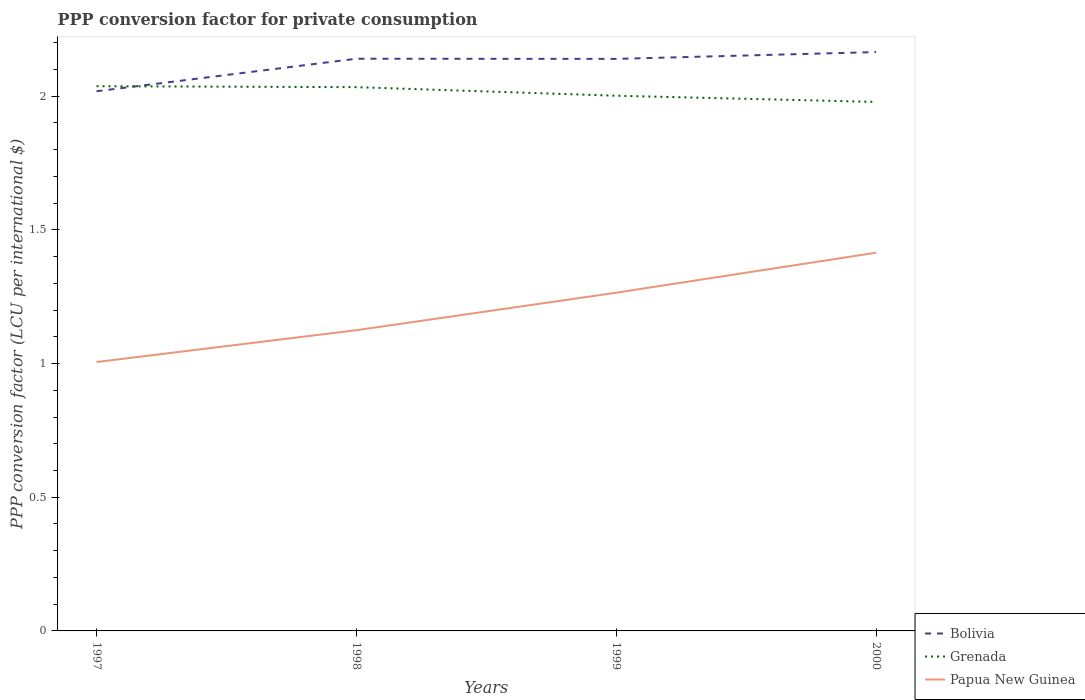Does the line corresponding to Bolivia intersect with the line corresponding to Grenada?
Provide a succinct answer. Yes. Is the number of lines equal to the number of legend labels?
Your answer should be very brief. Yes. Across all years, what is the maximum PPP conversion factor for private consumption in Grenada?
Make the answer very short. 1.98. In which year was the PPP conversion factor for private consumption in Grenada maximum?
Offer a very short reply. 2000. What is the total PPP conversion factor for private consumption in Bolivia in the graph?
Give a very brief answer. -0.03. What is the difference between the highest and the second highest PPP conversion factor for private consumption in Bolivia?
Give a very brief answer. 0.15. What is the difference between the highest and the lowest PPP conversion factor for private consumption in Grenada?
Your answer should be very brief. 2. Is the PPP conversion factor for private consumption in Papua New Guinea strictly greater than the PPP conversion factor for private consumption in Bolivia over the years?
Your answer should be compact. Yes. How many lines are there?
Your response must be concise. 3. What is the difference between two consecutive major ticks on the Y-axis?
Your answer should be very brief. 0.5. Does the graph contain any zero values?
Keep it short and to the point. No. Does the graph contain grids?
Offer a terse response. No. How are the legend labels stacked?
Offer a terse response. Vertical. What is the title of the graph?
Offer a terse response. PPP conversion factor for private consumption. Does "St. Vincent and the Grenadines" appear as one of the legend labels in the graph?
Give a very brief answer. No. What is the label or title of the X-axis?
Provide a succinct answer. Years. What is the label or title of the Y-axis?
Make the answer very short. PPP conversion factor (LCU per international $). What is the PPP conversion factor (LCU per international $) in Bolivia in 1997?
Offer a terse response. 2.02. What is the PPP conversion factor (LCU per international $) in Grenada in 1997?
Ensure brevity in your answer.  2.04. What is the PPP conversion factor (LCU per international $) in Papua New Guinea in 1997?
Your answer should be very brief. 1.01. What is the PPP conversion factor (LCU per international $) of Bolivia in 1998?
Provide a short and direct response. 2.14. What is the PPP conversion factor (LCU per international $) of Grenada in 1998?
Your answer should be very brief. 2.03. What is the PPP conversion factor (LCU per international $) in Papua New Guinea in 1998?
Offer a terse response. 1.12. What is the PPP conversion factor (LCU per international $) in Bolivia in 1999?
Offer a terse response. 2.14. What is the PPP conversion factor (LCU per international $) of Grenada in 1999?
Provide a succinct answer. 2. What is the PPP conversion factor (LCU per international $) in Papua New Guinea in 1999?
Offer a very short reply. 1.27. What is the PPP conversion factor (LCU per international $) of Bolivia in 2000?
Make the answer very short. 2.17. What is the PPP conversion factor (LCU per international $) of Grenada in 2000?
Provide a short and direct response. 1.98. What is the PPP conversion factor (LCU per international $) in Papua New Guinea in 2000?
Make the answer very short. 1.41. Across all years, what is the maximum PPP conversion factor (LCU per international $) of Bolivia?
Give a very brief answer. 2.17. Across all years, what is the maximum PPP conversion factor (LCU per international $) of Grenada?
Your answer should be compact. 2.04. Across all years, what is the maximum PPP conversion factor (LCU per international $) in Papua New Guinea?
Provide a short and direct response. 1.41. Across all years, what is the minimum PPP conversion factor (LCU per international $) of Bolivia?
Ensure brevity in your answer.  2.02. Across all years, what is the minimum PPP conversion factor (LCU per international $) in Grenada?
Make the answer very short. 1.98. Across all years, what is the minimum PPP conversion factor (LCU per international $) of Papua New Guinea?
Offer a very short reply. 1.01. What is the total PPP conversion factor (LCU per international $) in Bolivia in the graph?
Provide a succinct answer. 8.46. What is the total PPP conversion factor (LCU per international $) in Grenada in the graph?
Ensure brevity in your answer.  8.05. What is the total PPP conversion factor (LCU per international $) in Papua New Guinea in the graph?
Your response must be concise. 4.81. What is the difference between the PPP conversion factor (LCU per international $) in Bolivia in 1997 and that in 1998?
Provide a succinct answer. -0.12. What is the difference between the PPP conversion factor (LCU per international $) in Grenada in 1997 and that in 1998?
Give a very brief answer. 0. What is the difference between the PPP conversion factor (LCU per international $) of Papua New Guinea in 1997 and that in 1998?
Provide a short and direct response. -0.12. What is the difference between the PPP conversion factor (LCU per international $) in Bolivia in 1997 and that in 1999?
Your response must be concise. -0.12. What is the difference between the PPP conversion factor (LCU per international $) in Grenada in 1997 and that in 1999?
Give a very brief answer. 0.04. What is the difference between the PPP conversion factor (LCU per international $) of Papua New Guinea in 1997 and that in 1999?
Your answer should be compact. -0.26. What is the difference between the PPP conversion factor (LCU per international $) of Bolivia in 1997 and that in 2000?
Your answer should be very brief. -0.15. What is the difference between the PPP conversion factor (LCU per international $) of Grenada in 1997 and that in 2000?
Keep it short and to the point. 0.06. What is the difference between the PPP conversion factor (LCU per international $) in Papua New Guinea in 1997 and that in 2000?
Your answer should be very brief. -0.41. What is the difference between the PPP conversion factor (LCU per international $) in Bolivia in 1998 and that in 1999?
Provide a short and direct response. 0. What is the difference between the PPP conversion factor (LCU per international $) of Grenada in 1998 and that in 1999?
Keep it short and to the point. 0.03. What is the difference between the PPP conversion factor (LCU per international $) of Papua New Guinea in 1998 and that in 1999?
Your answer should be compact. -0.14. What is the difference between the PPP conversion factor (LCU per international $) in Bolivia in 1998 and that in 2000?
Your response must be concise. -0.02. What is the difference between the PPP conversion factor (LCU per international $) of Grenada in 1998 and that in 2000?
Ensure brevity in your answer.  0.06. What is the difference between the PPP conversion factor (LCU per international $) of Papua New Guinea in 1998 and that in 2000?
Offer a very short reply. -0.29. What is the difference between the PPP conversion factor (LCU per international $) in Bolivia in 1999 and that in 2000?
Provide a succinct answer. -0.03. What is the difference between the PPP conversion factor (LCU per international $) in Grenada in 1999 and that in 2000?
Your answer should be very brief. 0.02. What is the difference between the PPP conversion factor (LCU per international $) of Papua New Guinea in 1999 and that in 2000?
Offer a very short reply. -0.15. What is the difference between the PPP conversion factor (LCU per international $) in Bolivia in 1997 and the PPP conversion factor (LCU per international $) in Grenada in 1998?
Your response must be concise. -0.02. What is the difference between the PPP conversion factor (LCU per international $) of Bolivia in 1997 and the PPP conversion factor (LCU per international $) of Papua New Guinea in 1998?
Offer a terse response. 0.89. What is the difference between the PPP conversion factor (LCU per international $) of Grenada in 1997 and the PPP conversion factor (LCU per international $) of Papua New Guinea in 1998?
Keep it short and to the point. 0.91. What is the difference between the PPP conversion factor (LCU per international $) in Bolivia in 1997 and the PPP conversion factor (LCU per international $) in Grenada in 1999?
Offer a very short reply. 0.02. What is the difference between the PPP conversion factor (LCU per international $) in Bolivia in 1997 and the PPP conversion factor (LCU per international $) in Papua New Guinea in 1999?
Offer a very short reply. 0.75. What is the difference between the PPP conversion factor (LCU per international $) of Grenada in 1997 and the PPP conversion factor (LCU per international $) of Papua New Guinea in 1999?
Offer a very short reply. 0.77. What is the difference between the PPP conversion factor (LCU per international $) of Bolivia in 1997 and the PPP conversion factor (LCU per international $) of Grenada in 2000?
Provide a succinct answer. 0.04. What is the difference between the PPP conversion factor (LCU per international $) in Bolivia in 1997 and the PPP conversion factor (LCU per international $) in Papua New Guinea in 2000?
Make the answer very short. 0.6. What is the difference between the PPP conversion factor (LCU per international $) in Grenada in 1997 and the PPP conversion factor (LCU per international $) in Papua New Guinea in 2000?
Provide a short and direct response. 0.62. What is the difference between the PPP conversion factor (LCU per international $) of Bolivia in 1998 and the PPP conversion factor (LCU per international $) of Grenada in 1999?
Provide a short and direct response. 0.14. What is the difference between the PPP conversion factor (LCU per international $) in Bolivia in 1998 and the PPP conversion factor (LCU per international $) in Papua New Guinea in 1999?
Make the answer very short. 0.88. What is the difference between the PPP conversion factor (LCU per international $) in Grenada in 1998 and the PPP conversion factor (LCU per international $) in Papua New Guinea in 1999?
Ensure brevity in your answer.  0.77. What is the difference between the PPP conversion factor (LCU per international $) in Bolivia in 1998 and the PPP conversion factor (LCU per international $) in Grenada in 2000?
Offer a terse response. 0.16. What is the difference between the PPP conversion factor (LCU per international $) of Bolivia in 1998 and the PPP conversion factor (LCU per international $) of Papua New Guinea in 2000?
Ensure brevity in your answer.  0.73. What is the difference between the PPP conversion factor (LCU per international $) of Grenada in 1998 and the PPP conversion factor (LCU per international $) of Papua New Guinea in 2000?
Provide a short and direct response. 0.62. What is the difference between the PPP conversion factor (LCU per international $) of Bolivia in 1999 and the PPP conversion factor (LCU per international $) of Grenada in 2000?
Make the answer very short. 0.16. What is the difference between the PPP conversion factor (LCU per international $) in Bolivia in 1999 and the PPP conversion factor (LCU per international $) in Papua New Guinea in 2000?
Your answer should be very brief. 0.72. What is the difference between the PPP conversion factor (LCU per international $) in Grenada in 1999 and the PPP conversion factor (LCU per international $) in Papua New Guinea in 2000?
Your answer should be compact. 0.59. What is the average PPP conversion factor (LCU per international $) of Bolivia per year?
Provide a succinct answer. 2.12. What is the average PPP conversion factor (LCU per international $) of Grenada per year?
Your response must be concise. 2.01. What is the average PPP conversion factor (LCU per international $) of Papua New Guinea per year?
Your answer should be compact. 1.2. In the year 1997, what is the difference between the PPP conversion factor (LCU per international $) of Bolivia and PPP conversion factor (LCU per international $) of Grenada?
Your answer should be compact. -0.02. In the year 1997, what is the difference between the PPP conversion factor (LCU per international $) of Bolivia and PPP conversion factor (LCU per international $) of Papua New Guinea?
Your response must be concise. 1.01. In the year 1997, what is the difference between the PPP conversion factor (LCU per international $) of Grenada and PPP conversion factor (LCU per international $) of Papua New Guinea?
Your answer should be compact. 1.03. In the year 1998, what is the difference between the PPP conversion factor (LCU per international $) of Bolivia and PPP conversion factor (LCU per international $) of Grenada?
Provide a short and direct response. 0.11. In the year 1998, what is the difference between the PPP conversion factor (LCU per international $) of Bolivia and PPP conversion factor (LCU per international $) of Papua New Guinea?
Your answer should be very brief. 1.02. In the year 1999, what is the difference between the PPP conversion factor (LCU per international $) in Bolivia and PPP conversion factor (LCU per international $) in Grenada?
Your answer should be very brief. 0.14. In the year 1999, what is the difference between the PPP conversion factor (LCU per international $) of Bolivia and PPP conversion factor (LCU per international $) of Papua New Guinea?
Your response must be concise. 0.87. In the year 1999, what is the difference between the PPP conversion factor (LCU per international $) of Grenada and PPP conversion factor (LCU per international $) of Papua New Guinea?
Provide a short and direct response. 0.74. In the year 2000, what is the difference between the PPP conversion factor (LCU per international $) in Bolivia and PPP conversion factor (LCU per international $) in Grenada?
Keep it short and to the point. 0.19. In the year 2000, what is the difference between the PPP conversion factor (LCU per international $) in Bolivia and PPP conversion factor (LCU per international $) in Papua New Guinea?
Your answer should be very brief. 0.75. In the year 2000, what is the difference between the PPP conversion factor (LCU per international $) in Grenada and PPP conversion factor (LCU per international $) in Papua New Guinea?
Offer a very short reply. 0.56. What is the ratio of the PPP conversion factor (LCU per international $) of Bolivia in 1997 to that in 1998?
Your response must be concise. 0.94. What is the ratio of the PPP conversion factor (LCU per international $) of Grenada in 1997 to that in 1998?
Provide a short and direct response. 1. What is the ratio of the PPP conversion factor (LCU per international $) in Papua New Guinea in 1997 to that in 1998?
Your answer should be very brief. 0.89. What is the ratio of the PPP conversion factor (LCU per international $) in Bolivia in 1997 to that in 1999?
Keep it short and to the point. 0.94. What is the ratio of the PPP conversion factor (LCU per international $) in Grenada in 1997 to that in 1999?
Offer a very short reply. 1.02. What is the ratio of the PPP conversion factor (LCU per international $) of Papua New Guinea in 1997 to that in 1999?
Offer a terse response. 0.8. What is the ratio of the PPP conversion factor (LCU per international $) of Bolivia in 1997 to that in 2000?
Give a very brief answer. 0.93. What is the ratio of the PPP conversion factor (LCU per international $) of Grenada in 1997 to that in 2000?
Your answer should be very brief. 1.03. What is the ratio of the PPP conversion factor (LCU per international $) of Papua New Guinea in 1997 to that in 2000?
Ensure brevity in your answer.  0.71. What is the ratio of the PPP conversion factor (LCU per international $) of Grenada in 1998 to that in 1999?
Offer a terse response. 1.02. What is the ratio of the PPP conversion factor (LCU per international $) in Papua New Guinea in 1998 to that in 1999?
Your answer should be very brief. 0.89. What is the ratio of the PPP conversion factor (LCU per international $) of Grenada in 1998 to that in 2000?
Your response must be concise. 1.03. What is the ratio of the PPP conversion factor (LCU per international $) of Papua New Guinea in 1998 to that in 2000?
Offer a very short reply. 0.8. What is the ratio of the PPP conversion factor (LCU per international $) of Grenada in 1999 to that in 2000?
Offer a terse response. 1.01. What is the ratio of the PPP conversion factor (LCU per international $) of Papua New Guinea in 1999 to that in 2000?
Your response must be concise. 0.89. What is the difference between the highest and the second highest PPP conversion factor (LCU per international $) in Bolivia?
Your response must be concise. 0.02. What is the difference between the highest and the second highest PPP conversion factor (LCU per international $) in Grenada?
Ensure brevity in your answer.  0. What is the difference between the highest and the second highest PPP conversion factor (LCU per international $) of Papua New Guinea?
Keep it short and to the point. 0.15. What is the difference between the highest and the lowest PPP conversion factor (LCU per international $) in Bolivia?
Offer a very short reply. 0.15. What is the difference between the highest and the lowest PPP conversion factor (LCU per international $) in Grenada?
Offer a terse response. 0.06. What is the difference between the highest and the lowest PPP conversion factor (LCU per international $) of Papua New Guinea?
Your answer should be very brief. 0.41. 